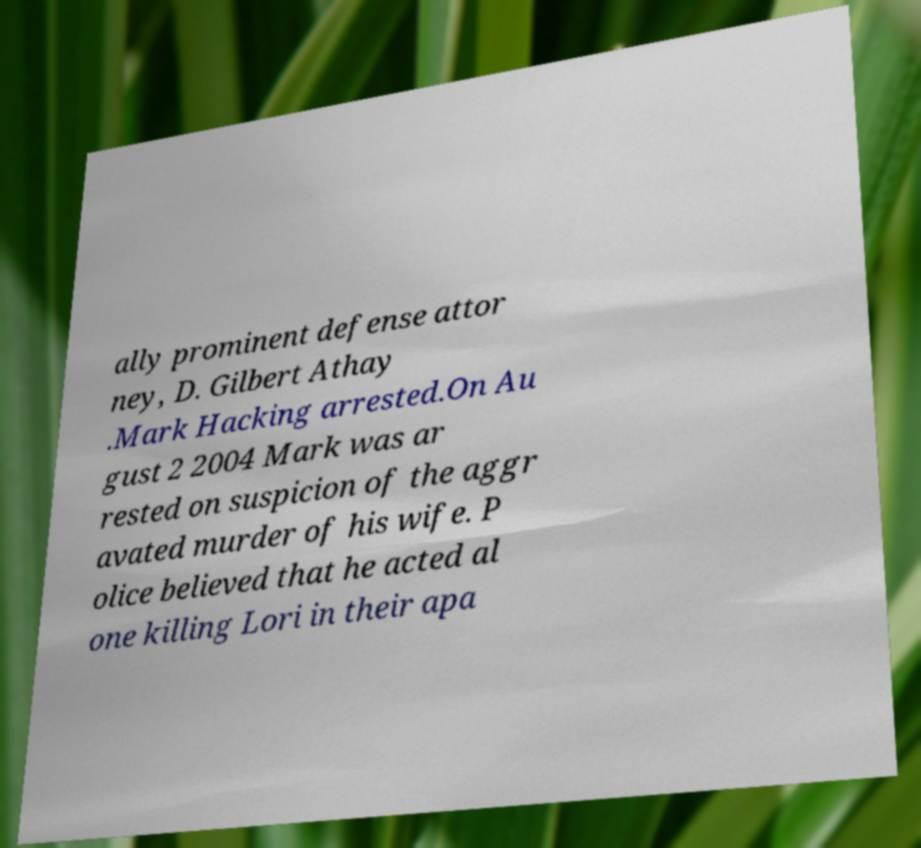I need the written content from this picture converted into text. Can you do that? ally prominent defense attor ney, D. Gilbert Athay .Mark Hacking arrested.On Au gust 2 2004 Mark was ar rested on suspicion of the aggr avated murder of his wife. P olice believed that he acted al one killing Lori in their apa 